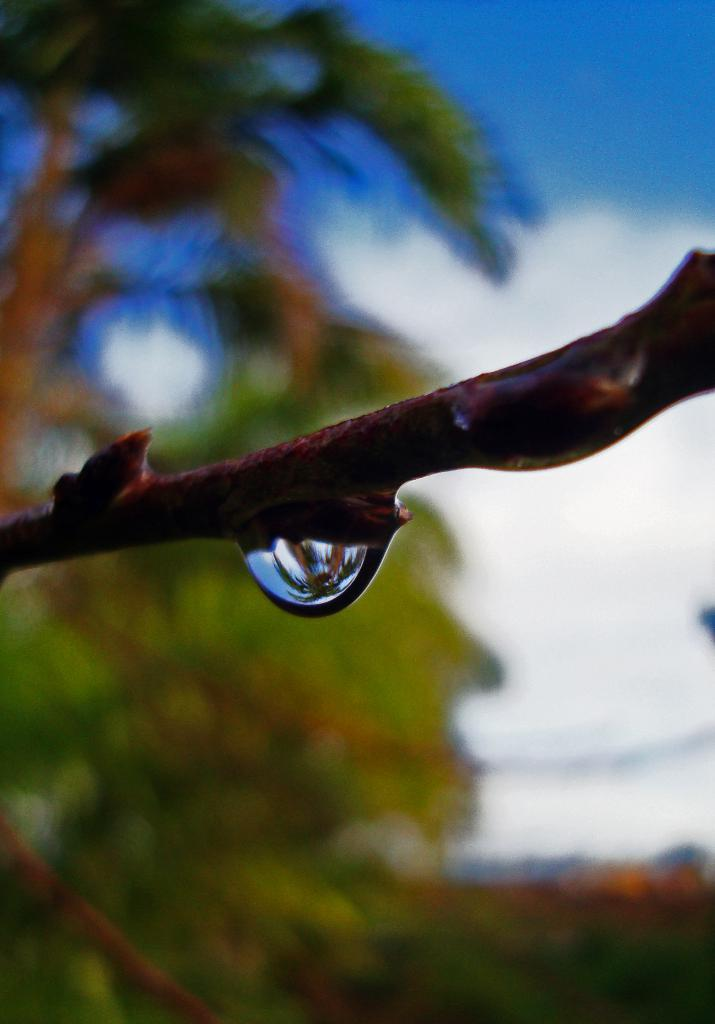What is the main subject of the image? The main subject of the image is a stem with a water drop. What is the appearance of the background in the image? The background of the image is blurred. What type of natural elements can be seen in the background of the image? Trees and the sky are visible in the background of the image. What type of respect can be seen in the image? There is no indication of respect in the image; it features a stem with a water drop and a blurred background. What scent is associated with the water drop in the image? There is no mention of scent in the image, as it only shows a stem with a water drop and a blurred background. 